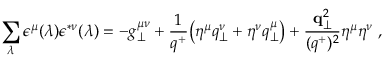Convert formula to latex. <formula><loc_0><loc_0><loc_500><loc_500>\sum _ { \lambda } \epsilon ^ { \mu } ( \lambda ) \epsilon ^ { * \nu } ( \lambda ) = - g _ { \perp } ^ { \mu \nu } + { \frac { 1 } { q ^ { + } } } \left ( \eta ^ { \mu } q _ { \perp } ^ { \nu } + \eta ^ { \nu } q _ { \perp } ^ { \mu } \right ) + { \frac { { q } _ { \perp } ^ { 2 } } { ( q ^ { + } ) ^ { 2 } } } \eta ^ { \mu } \eta ^ { \nu } \, ,</formula> 